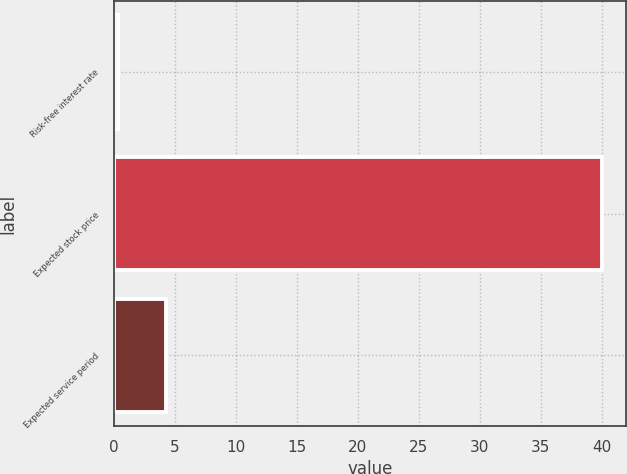<chart> <loc_0><loc_0><loc_500><loc_500><bar_chart><fcel>Risk-free interest rate<fcel>Expected stock price<fcel>Expected service period<nl><fcel>0.3<fcel>40<fcel>4.27<nl></chart> 